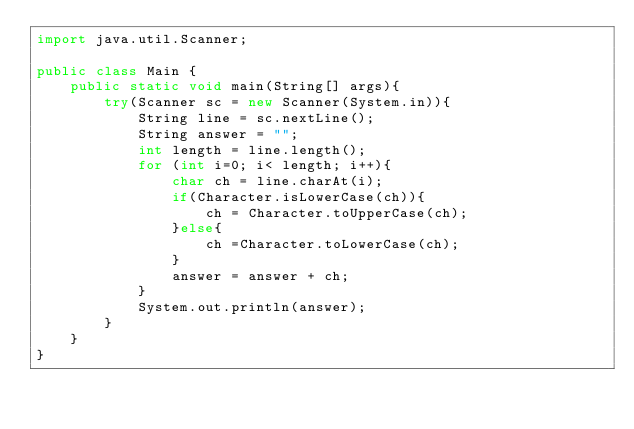<code> <loc_0><loc_0><loc_500><loc_500><_Java_>import java.util.Scanner;

public class Main {
    public static void main(String[] args){
        try(Scanner sc = new Scanner(System.in)){
            String line = sc.nextLine();
            String answer = "";
            int length = line.length();
            for (int i=0; i< length; i++){
                char ch = line.charAt(i);
                if(Character.isLowerCase(ch)){
                    ch = Character.toUpperCase(ch);
                }else{
                    ch =Character.toLowerCase(ch);
                }
                answer = answer + ch;
            }
            System.out.println(answer);
        }
    }
}
</code> 